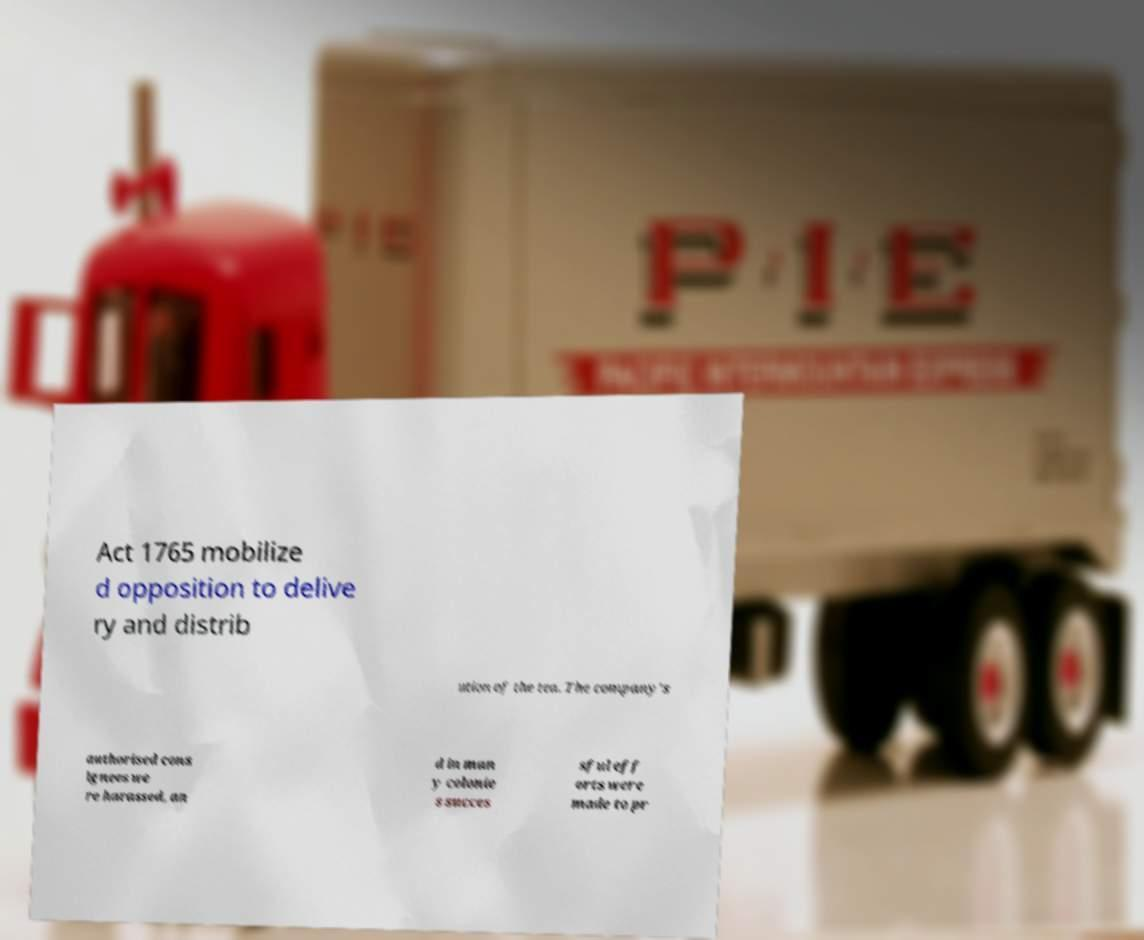Please read and relay the text visible in this image. What does it say? Act 1765 mobilize d opposition to delive ry and distrib ution of the tea. The company's authorised cons ignees we re harassed, an d in man y colonie s succes sful eff orts were made to pr 